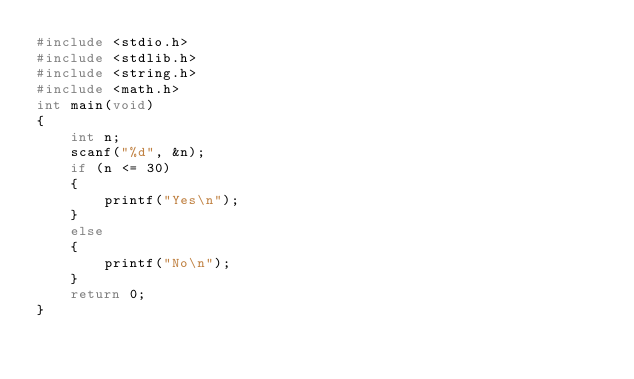Convert code to text. <code><loc_0><loc_0><loc_500><loc_500><_C_>#include <stdio.h>
#include <stdlib.h>
#include <string.h>
#include <math.h>
int main(void)
{
    int n;
    scanf("%d", &n);
    if (n <= 30)
    {
        printf("Yes\n");
    }
    else
    {
        printf("No\n");
    }
    return 0;
}</code> 